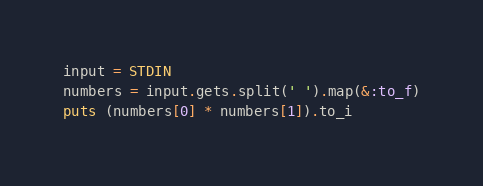<code> <loc_0><loc_0><loc_500><loc_500><_Ruby_>input = STDIN
numbers = input.gets.split(' ').map(&:to_f)
puts (numbers[0] * numbers[1]).to_i
</code> 